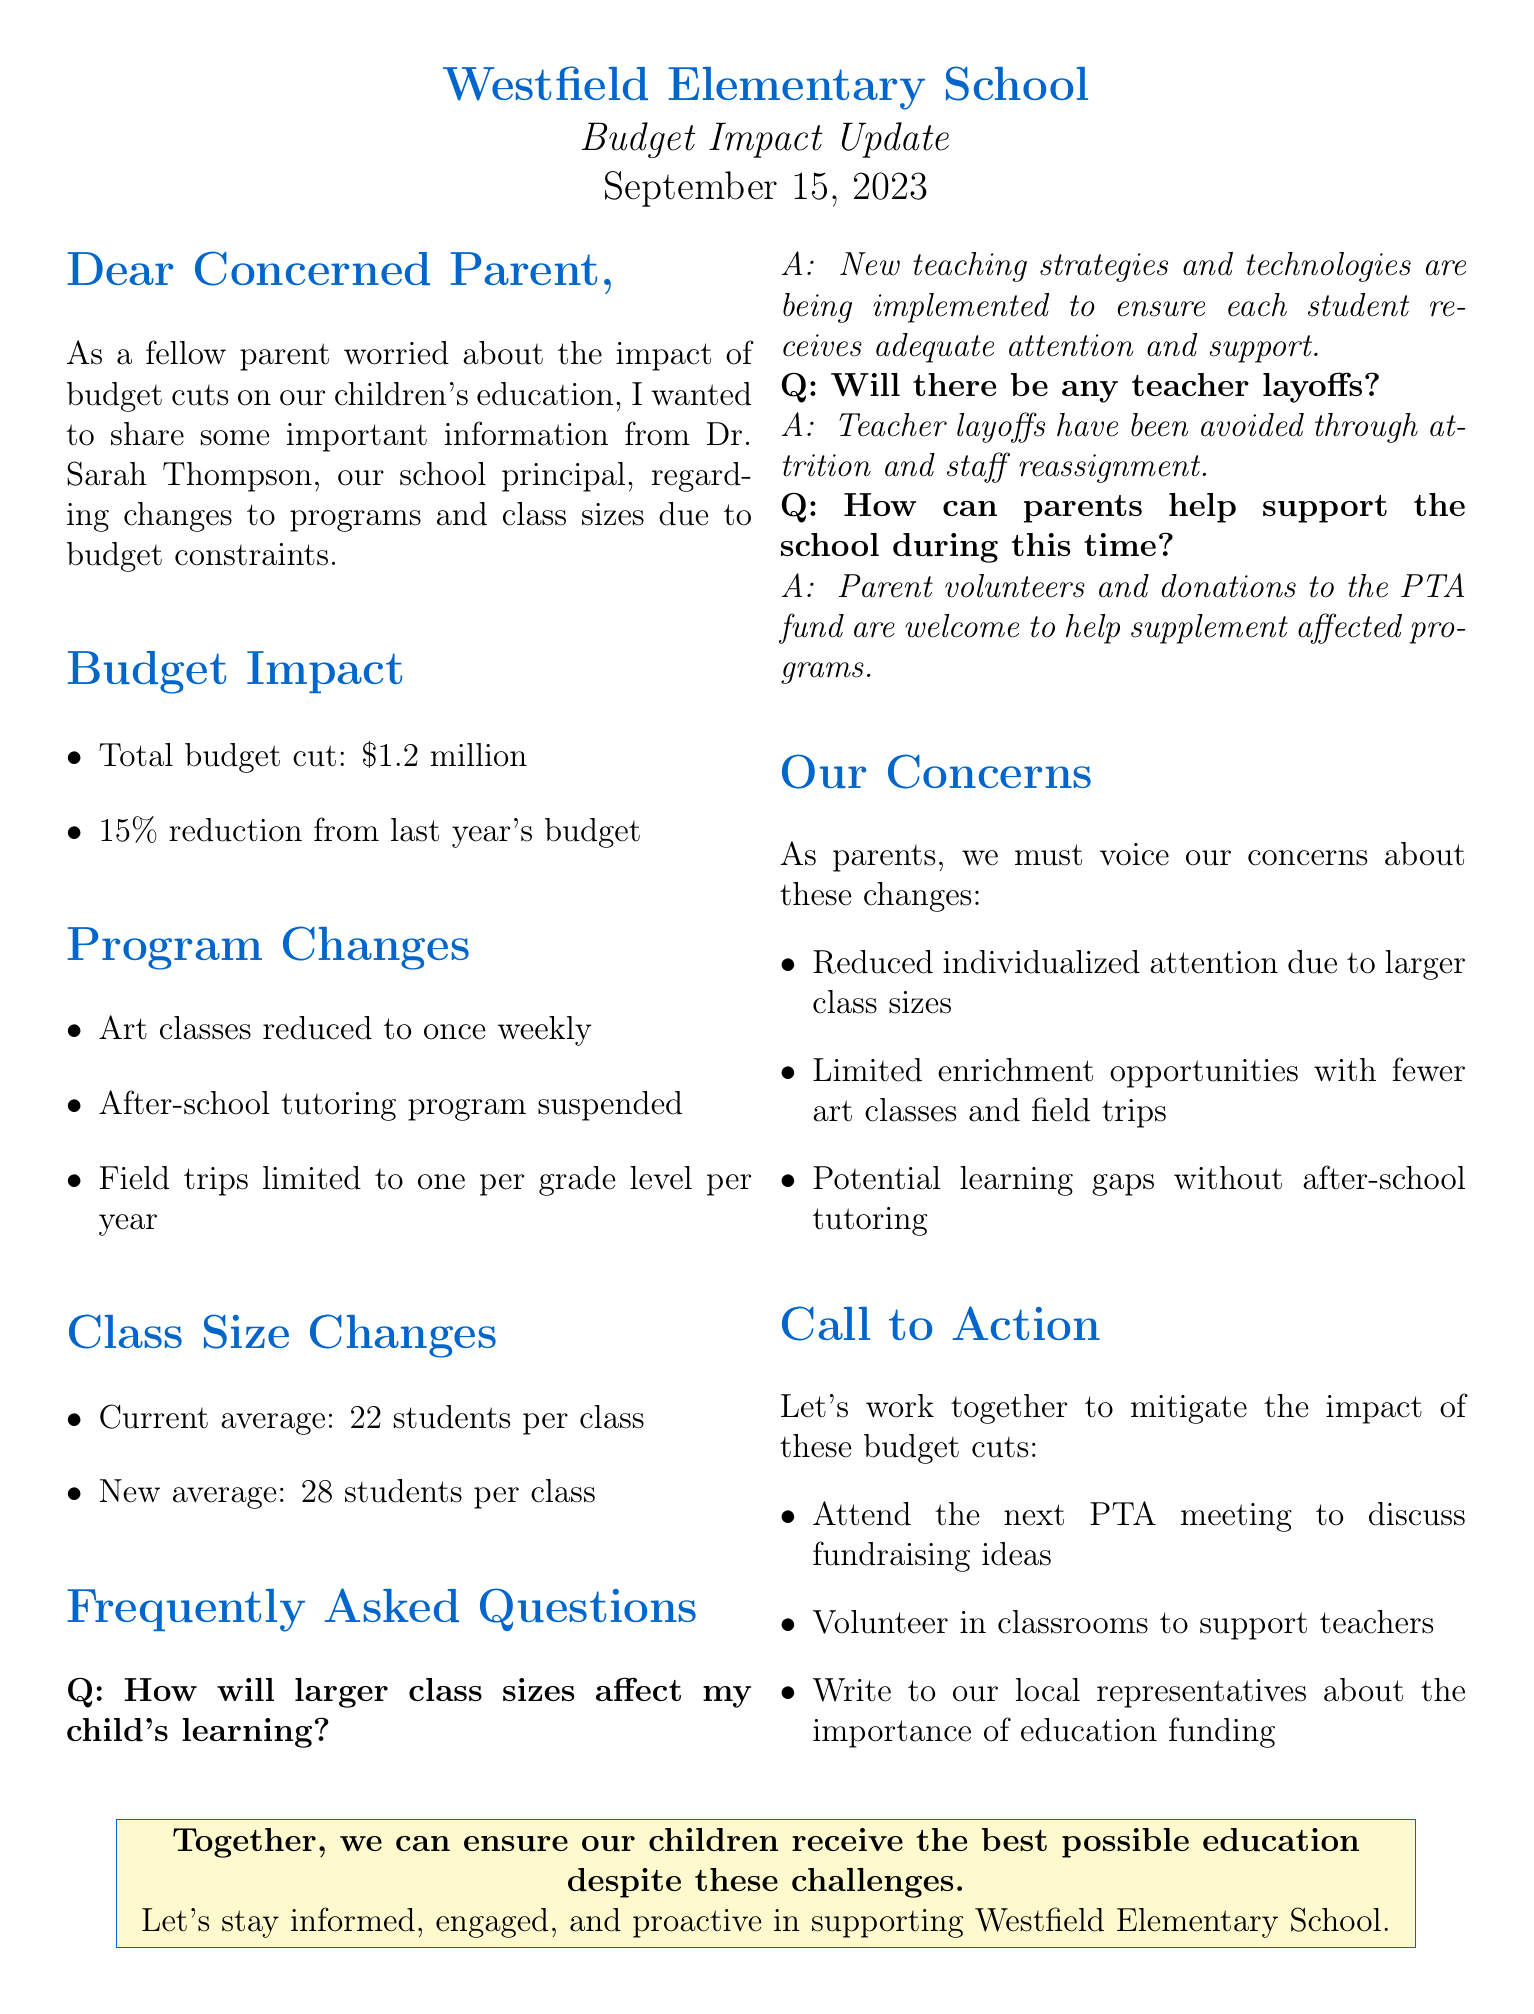What is the principal's name? The name of the principal is mentioned at the beginning of the document, which is Dr. Sarah Thompson.
Answer: Dr. Sarah Thompson When was the newsletter issued? The date of the newsletter is specified in the header of the document as September 15, 2023.
Answer: September 15, 2023 What is the total budget cut amount? The document states that the total budget cut is $1.2 million, which is one of the key figures addressed.
Answer: $1.2 million How many students will be in the new average class size? The document outlines the upcoming class size changes, highlighting that the new average will be 28 students per class.
Answer: 28 students What was the original frequency of art classes? The newsletter specifies that art classes were originally scheduled to occur twice weekly before the changes were announced.
Answer: Twice weekly How can parents support the school during this time? One of the FAQs addresses how parents can help, specifically mentioning parent volunteers and donations to the PTA fund.
Answer: Parent volunteers and donations to the PTA fund What might be a potential learning gap consequence of these changes? The document notes that the suspension of the after-school tutoring program could create potential learning gaps for students.
Answer: Learning gaps What is the percentage reduction from last year's budget? The newsletter indicates that the budget has been reduced by 15% from the previous year, which is a significant piece of information.
Answer: 15% What does the school welcome from parents? The document expresses that the school welcomes participation from parents, guiding them on how they can assist during the budget constraints.
Answer: Participation and support 